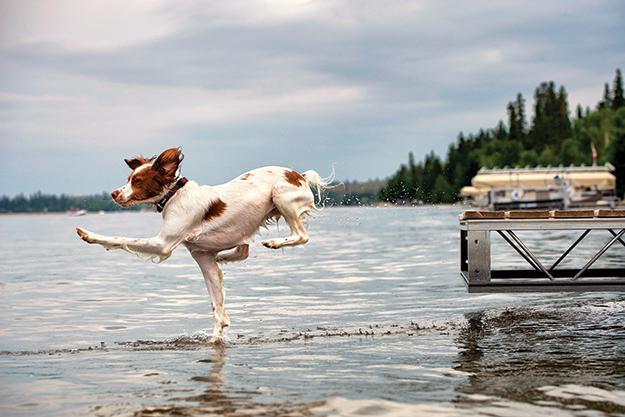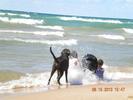The first image is the image on the left, the second image is the image on the right. Examine the images to the left and right. Is the description "The right image contains no more than three dogs." accurate? Answer yes or no. Yes. 